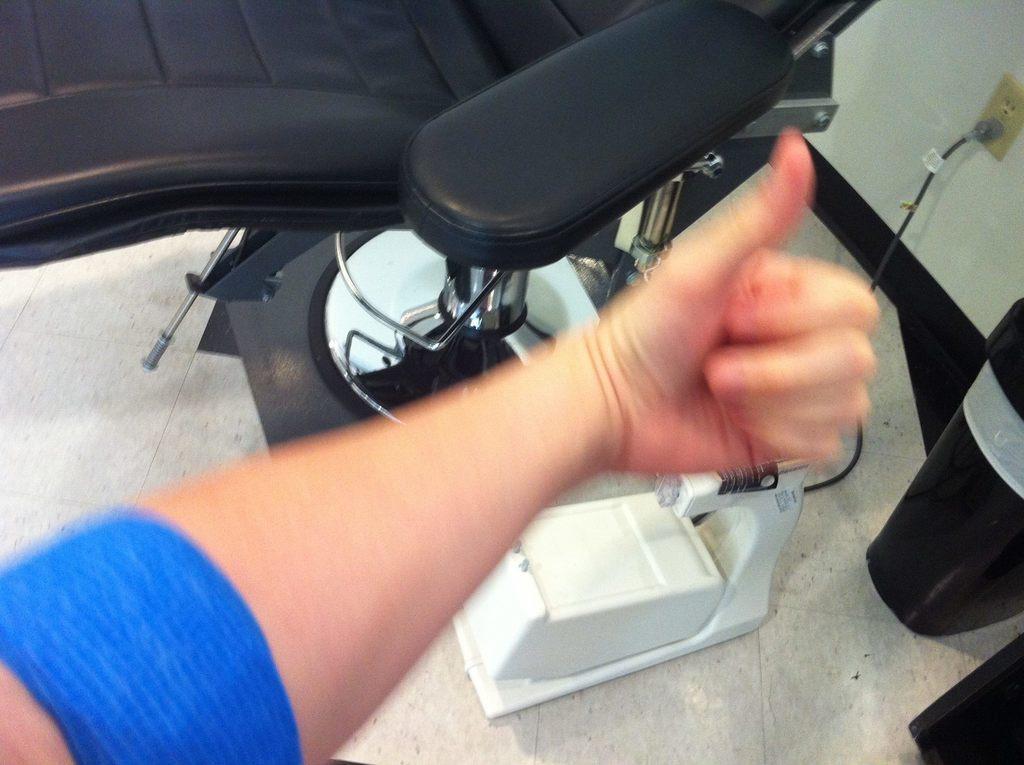Please provide a concise description of this image. In this image, we can see the hand of a person, there is a black chair. On the right side, we can see the wall and there is a switchboard on the wall. 